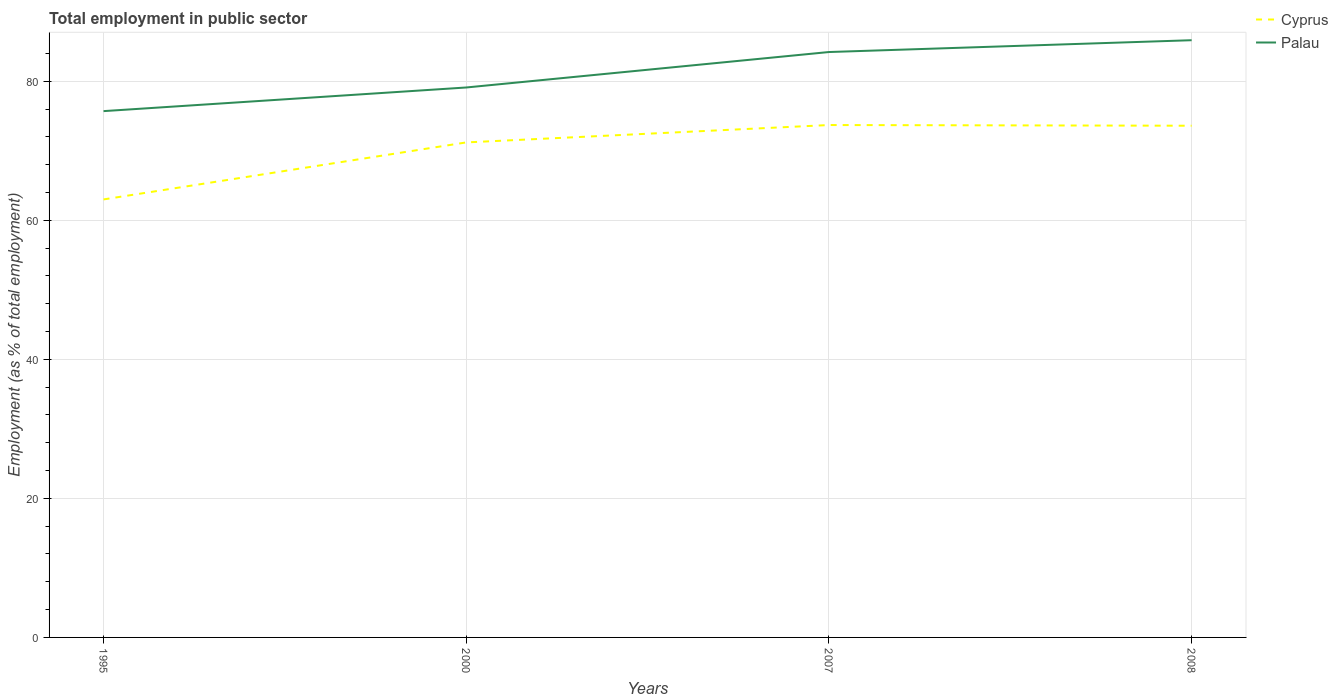Across all years, what is the maximum employment in public sector in Palau?
Provide a succinct answer. 75.7. What is the total employment in public sector in Cyprus in the graph?
Make the answer very short. -2.5. What is the difference between the highest and the second highest employment in public sector in Cyprus?
Provide a succinct answer. 10.7. Is the employment in public sector in Palau strictly greater than the employment in public sector in Cyprus over the years?
Ensure brevity in your answer.  No. How many years are there in the graph?
Your response must be concise. 4. What is the difference between two consecutive major ticks on the Y-axis?
Your answer should be very brief. 20. How many legend labels are there?
Your answer should be compact. 2. How are the legend labels stacked?
Your answer should be very brief. Vertical. What is the title of the graph?
Offer a terse response. Total employment in public sector. What is the label or title of the Y-axis?
Make the answer very short. Employment (as % of total employment). What is the Employment (as % of total employment) of Palau in 1995?
Offer a terse response. 75.7. What is the Employment (as % of total employment) of Cyprus in 2000?
Your response must be concise. 71.2. What is the Employment (as % of total employment) in Palau in 2000?
Offer a very short reply. 79.1. What is the Employment (as % of total employment) in Cyprus in 2007?
Provide a succinct answer. 73.7. What is the Employment (as % of total employment) in Palau in 2007?
Offer a very short reply. 84.2. What is the Employment (as % of total employment) of Cyprus in 2008?
Your answer should be very brief. 73.6. What is the Employment (as % of total employment) in Palau in 2008?
Your answer should be very brief. 85.9. Across all years, what is the maximum Employment (as % of total employment) of Cyprus?
Offer a very short reply. 73.7. Across all years, what is the maximum Employment (as % of total employment) of Palau?
Keep it short and to the point. 85.9. Across all years, what is the minimum Employment (as % of total employment) of Cyprus?
Give a very brief answer. 63. Across all years, what is the minimum Employment (as % of total employment) of Palau?
Your response must be concise. 75.7. What is the total Employment (as % of total employment) in Cyprus in the graph?
Keep it short and to the point. 281.5. What is the total Employment (as % of total employment) of Palau in the graph?
Provide a succinct answer. 324.9. What is the difference between the Employment (as % of total employment) in Cyprus in 1995 and that in 2000?
Your answer should be compact. -8.2. What is the difference between the Employment (as % of total employment) of Cyprus in 1995 and that in 2007?
Offer a terse response. -10.7. What is the difference between the Employment (as % of total employment) of Cyprus in 2000 and that in 2008?
Keep it short and to the point. -2.4. What is the difference between the Employment (as % of total employment) of Palau in 2000 and that in 2008?
Your answer should be very brief. -6.8. What is the difference between the Employment (as % of total employment) in Cyprus in 2007 and that in 2008?
Offer a terse response. 0.1. What is the difference between the Employment (as % of total employment) in Palau in 2007 and that in 2008?
Your answer should be very brief. -1.7. What is the difference between the Employment (as % of total employment) of Cyprus in 1995 and the Employment (as % of total employment) of Palau in 2000?
Give a very brief answer. -16.1. What is the difference between the Employment (as % of total employment) of Cyprus in 1995 and the Employment (as % of total employment) of Palau in 2007?
Provide a succinct answer. -21.2. What is the difference between the Employment (as % of total employment) in Cyprus in 1995 and the Employment (as % of total employment) in Palau in 2008?
Give a very brief answer. -22.9. What is the difference between the Employment (as % of total employment) in Cyprus in 2000 and the Employment (as % of total employment) in Palau in 2007?
Your response must be concise. -13. What is the difference between the Employment (as % of total employment) in Cyprus in 2000 and the Employment (as % of total employment) in Palau in 2008?
Provide a short and direct response. -14.7. What is the average Employment (as % of total employment) in Cyprus per year?
Make the answer very short. 70.38. What is the average Employment (as % of total employment) of Palau per year?
Offer a terse response. 81.22. In the year 1995, what is the difference between the Employment (as % of total employment) of Cyprus and Employment (as % of total employment) of Palau?
Ensure brevity in your answer.  -12.7. In the year 2008, what is the difference between the Employment (as % of total employment) in Cyprus and Employment (as % of total employment) in Palau?
Your answer should be very brief. -12.3. What is the ratio of the Employment (as % of total employment) in Cyprus in 1995 to that in 2000?
Your answer should be compact. 0.88. What is the ratio of the Employment (as % of total employment) in Palau in 1995 to that in 2000?
Make the answer very short. 0.96. What is the ratio of the Employment (as % of total employment) in Cyprus in 1995 to that in 2007?
Keep it short and to the point. 0.85. What is the ratio of the Employment (as % of total employment) in Palau in 1995 to that in 2007?
Your answer should be very brief. 0.9. What is the ratio of the Employment (as % of total employment) of Cyprus in 1995 to that in 2008?
Ensure brevity in your answer.  0.86. What is the ratio of the Employment (as % of total employment) of Palau in 1995 to that in 2008?
Your response must be concise. 0.88. What is the ratio of the Employment (as % of total employment) in Cyprus in 2000 to that in 2007?
Give a very brief answer. 0.97. What is the ratio of the Employment (as % of total employment) in Palau in 2000 to that in 2007?
Your answer should be compact. 0.94. What is the ratio of the Employment (as % of total employment) in Cyprus in 2000 to that in 2008?
Your answer should be very brief. 0.97. What is the ratio of the Employment (as % of total employment) in Palau in 2000 to that in 2008?
Provide a succinct answer. 0.92. What is the ratio of the Employment (as % of total employment) in Palau in 2007 to that in 2008?
Make the answer very short. 0.98. What is the difference between the highest and the lowest Employment (as % of total employment) in Cyprus?
Ensure brevity in your answer.  10.7. What is the difference between the highest and the lowest Employment (as % of total employment) in Palau?
Your response must be concise. 10.2. 